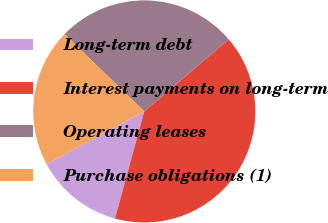Convert chart to OTSL. <chart><loc_0><loc_0><loc_500><loc_500><pie_chart><fcel>Long-term debt<fcel>Interest payments on long-term<fcel>Operating leases<fcel>Purchase obligations (1)<nl><fcel>12.86%<fcel>40.5%<fcel>26.51%<fcel>20.14%<nl></chart> 